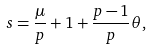Convert formula to latex. <formula><loc_0><loc_0><loc_500><loc_500>s = \frac { \mu } { p } + 1 + \frac { p - 1 } { p } \theta ,</formula> 